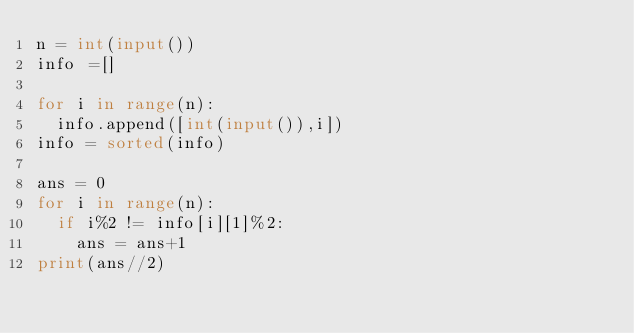<code> <loc_0><loc_0><loc_500><loc_500><_Python_>n = int(input())
info =[]

for i in range(n):
  info.append([int(input()),i])
info = sorted(info)
  
ans = 0
for i in range(n):
  if i%2 != info[i][1]%2:
    ans = ans+1
print(ans//2)</code> 